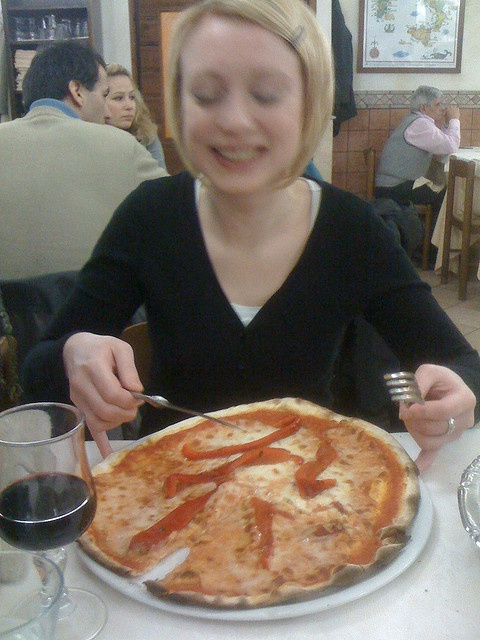Describe the objects in this image and their specific colors. I can see people in darkgray, black, and gray tones, pizza in darkgray, tan, salmon, and brown tones, people in darkgray and gray tones, dining table in darkgray and lightgray tones, and wine glass in darkgray, black, and gray tones in this image. 